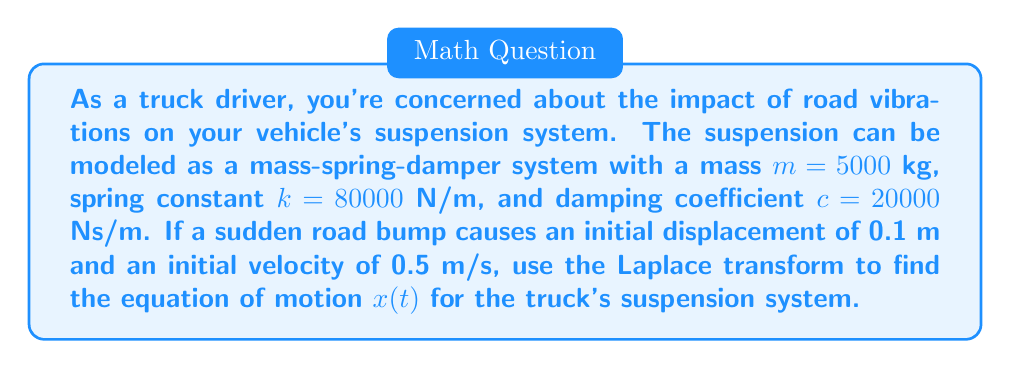Can you solve this math problem? Let's approach this step-by-step using Laplace transforms:

1) The general equation of motion for a mass-spring-damper system is:

   $$m\frac{d^2x}{dt^2} + c\frac{dx}{dt} + kx = 0$$

2) Taking the Laplace transform of both sides, we get:

   $$m(s^2X(s) - sx(0) - x'(0)) + c(sX(s) - x(0)) + kX(s) = 0$$

3) Substituting the given values:
   $m = 5000$, $k = 80000$, $c = 20000$, $x(0) = 0.1$, $x'(0) = 0.5$

   $$5000(s^2X(s) - 0.1s - 0.5) + 20000(sX(s) - 0.1) + 80000X(s) = 0$$

4) Simplifying:

   $$5000s^2X(s) + 20000sX(s) + 80000X(s) = 500s + 2500 + 2000$$

   $$(5000s^2 + 20000s + 80000)X(s) = 500s + 4500$$

5) Solving for $X(s)$:

   $$X(s) = \frac{500s + 4500}{5000s^2 + 20000s + 80000}$$

6) This can be rewritten as:

   $$X(s) = \frac{0.1s + 0.9}{s^2 + 4s + 16}$$

7) To find $x(t)$, we need to take the inverse Laplace transform. The denominator can be factored as $(s+2)^2 + 12$, which corresponds to a damped oscillation.

8) The inverse Laplace transform is:

   $$x(t) = e^{-2t}(0.1\cos(\sqrt{12}t) + \frac{0.9 + 0.2}{\sqrt{12}}\sin(\sqrt{12}t))$$

9) Simplifying:

   $$x(t) = e^{-2t}(0.1\cos(\sqrt{12}t) + \frac{1.1}{\sqrt{12}}\sin(\sqrt{12}t))$$
Answer: $$x(t) = e^{-2t}(0.1\cos(\sqrt{12}t) + \frac{1.1}{\sqrt{12}}\sin(\sqrt{12}t))$$ 